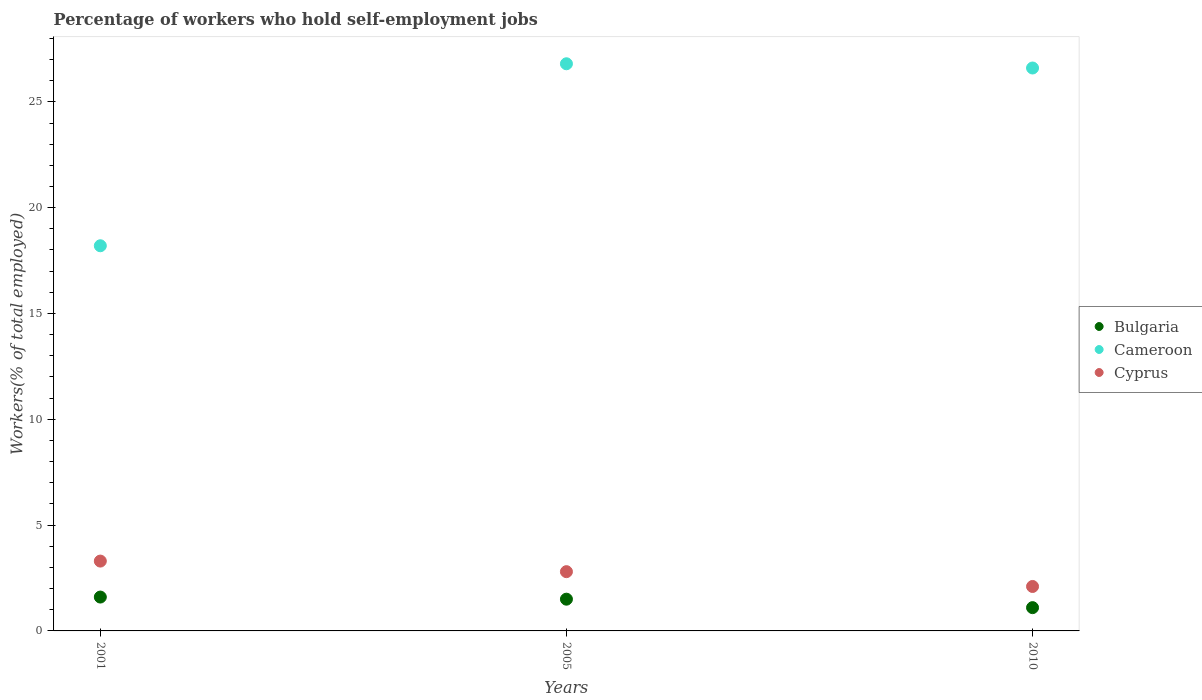How many different coloured dotlines are there?
Make the answer very short. 3. What is the percentage of self-employed workers in Cyprus in 2001?
Provide a succinct answer. 3.3. Across all years, what is the maximum percentage of self-employed workers in Cyprus?
Make the answer very short. 3.3. Across all years, what is the minimum percentage of self-employed workers in Bulgaria?
Your answer should be very brief. 1.1. In which year was the percentage of self-employed workers in Bulgaria maximum?
Offer a very short reply. 2001. What is the total percentage of self-employed workers in Bulgaria in the graph?
Your response must be concise. 4.2. What is the difference between the percentage of self-employed workers in Cameroon in 2005 and that in 2010?
Offer a very short reply. 0.2. What is the difference between the percentage of self-employed workers in Cameroon in 2005 and the percentage of self-employed workers in Bulgaria in 2010?
Make the answer very short. 25.7. What is the average percentage of self-employed workers in Cyprus per year?
Keep it short and to the point. 2.73. In the year 2010, what is the difference between the percentage of self-employed workers in Cameroon and percentage of self-employed workers in Bulgaria?
Ensure brevity in your answer.  25.5. In how many years, is the percentage of self-employed workers in Bulgaria greater than 6 %?
Offer a very short reply. 0. What is the ratio of the percentage of self-employed workers in Cameroon in 2001 to that in 2005?
Your answer should be compact. 0.68. Is the difference between the percentage of self-employed workers in Cameroon in 2001 and 2010 greater than the difference between the percentage of self-employed workers in Bulgaria in 2001 and 2010?
Offer a terse response. No. What is the difference between the highest and the lowest percentage of self-employed workers in Cameroon?
Ensure brevity in your answer.  8.6. Is the sum of the percentage of self-employed workers in Bulgaria in 2001 and 2005 greater than the maximum percentage of self-employed workers in Cameroon across all years?
Offer a terse response. No. Is it the case that in every year, the sum of the percentage of self-employed workers in Cameroon and percentage of self-employed workers in Bulgaria  is greater than the percentage of self-employed workers in Cyprus?
Make the answer very short. Yes. Does the percentage of self-employed workers in Bulgaria monotonically increase over the years?
Offer a very short reply. No. Is the percentage of self-employed workers in Cameroon strictly less than the percentage of self-employed workers in Bulgaria over the years?
Offer a very short reply. No. How many dotlines are there?
Ensure brevity in your answer.  3. How many years are there in the graph?
Your answer should be very brief. 3. What is the difference between two consecutive major ticks on the Y-axis?
Give a very brief answer. 5. Does the graph contain any zero values?
Offer a very short reply. No. Does the graph contain grids?
Offer a terse response. No. Where does the legend appear in the graph?
Your answer should be very brief. Center right. How many legend labels are there?
Give a very brief answer. 3. What is the title of the graph?
Ensure brevity in your answer.  Percentage of workers who hold self-employment jobs. Does "Virgin Islands" appear as one of the legend labels in the graph?
Ensure brevity in your answer.  No. What is the label or title of the X-axis?
Provide a succinct answer. Years. What is the label or title of the Y-axis?
Offer a terse response. Workers(% of total employed). What is the Workers(% of total employed) in Bulgaria in 2001?
Provide a succinct answer. 1.6. What is the Workers(% of total employed) of Cameroon in 2001?
Offer a terse response. 18.2. What is the Workers(% of total employed) in Cyprus in 2001?
Your answer should be very brief. 3.3. What is the Workers(% of total employed) of Cameroon in 2005?
Provide a short and direct response. 26.8. What is the Workers(% of total employed) of Cyprus in 2005?
Provide a succinct answer. 2.8. What is the Workers(% of total employed) of Bulgaria in 2010?
Offer a very short reply. 1.1. What is the Workers(% of total employed) of Cameroon in 2010?
Keep it short and to the point. 26.6. What is the Workers(% of total employed) of Cyprus in 2010?
Ensure brevity in your answer.  2.1. Across all years, what is the maximum Workers(% of total employed) of Bulgaria?
Ensure brevity in your answer.  1.6. Across all years, what is the maximum Workers(% of total employed) in Cameroon?
Your response must be concise. 26.8. Across all years, what is the maximum Workers(% of total employed) of Cyprus?
Provide a short and direct response. 3.3. Across all years, what is the minimum Workers(% of total employed) of Bulgaria?
Provide a succinct answer. 1.1. Across all years, what is the minimum Workers(% of total employed) in Cameroon?
Keep it short and to the point. 18.2. Across all years, what is the minimum Workers(% of total employed) of Cyprus?
Ensure brevity in your answer.  2.1. What is the total Workers(% of total employed) of Cameroon in the graph?
Make the answer very short. 71.6. What is the difference between the Workers(% of total employed) of Bulgaria in 2001 and that in 2005?
Your answer should be compact. 0.1. What is the difference between the Workers(% of total employed) of Bulgaria in 2001 and that in 2010?
Provide a short and direct response. 0.5. What is the difference between the Workers(% of total employed) of Cameroon in 2001 and that in 2010?
Give a very brief answer. -8.4. What is the difference between the Workers(% of total employed) of Bulgaria in 2005 and that in 2010?
Keep it short and to the point. 0.4. What is the difference between the Workers(% of total employed) in Cameroon in 2005 and that in 2010?
Ensure brevity in your answer.  0.2. What is the difference between the Workers(% of total employed) in Bulgaria in 2001 and the Workers(% of total employed) in Cameroon in 2005?
Your answer should be very brief. -25.2. What is the difference between the Workers(% of total employed) in Cameroon in 2001 and the Workers(% of total employed) in Cyprus in 2005?
Offer a terse response. 15.4. What is the difference between the Workers(% of total employed) in Cameroon in 2001 and the Workers(% of total employed) in Cyprus in 2010?
Offer a terse response. 16.1. What is the difference between the Workers(% of total employed) of Bulgaria in 2005 and the Workers(% of total employed) of Cameroon in 2010?
Offer a terse response. -25.1. What is the difference between the Workers(% of total employed) in Bulgaria in 2005 and the Workers(% of total employed) in Cyprus in 2010?
Offer a terse response. -0.6. What is the difference between the Workers(% of total employed) in Cameroon in 2005 and the Workers(% of total employed) in Cyprus in 2010?
Your answer should be compact. 24.7. What is the average Workers(% of total employed) in Cameroon per year?
Provide a succinct answer. 23.87. What is the average Workers(% of total employed) in Cyprus per year?
Provide a short and direct response. 2.73. In the year 2001, what is the difference between the Workers(% of total employed) in Bulgaria and Workers(% of total employed) in Cameroon?
Give a very brief answer. -16.6. In the year 2001, what is the difference between the Workers(% of total employed) in Bulgaria and Workers(% of total employed) in Cyprus?
Your response must be concise. -1.7. In the year 2001, what is the difference between the Workers(% of total employed) in Cameroon and Workers(% of total employed) in Cyprus?
Offer a very short reply. 14.9. In the year 2005, what is the difference between the Workers(% of total employed) in Bulgaria and Workers(% of total employed) in Cameroon?
Provide a succinct answer. -25.3. In the year 2010, what is the difference between the Workers(% of total employed) in Bulgaria and Workers(% of total employed) in Cameroon?
Keep it short and to the point. -25.5. In the year 2010, what is the difference between the Workers(% of total employed) in Bulgaria and Workers(% of total employed) in Cyprus?
Give a very brief answer. -1. In the year 2010, what is the difference between the Workers(% of total employed) of Cameroon and Workers(% of total employed) of Cyprus?
Your answer should be very brief. 24.5. What is the ratio of the Workers(% of total employed) in Bulgaria in 2001 to that in 2005?
Make the answer very short. 1.07. What is the ratio of the Workers(% of total employed) of Cameroon in 2001 to that in 2005?
Your answer should be compact. 0.68. What is the ratio of the Workers(% of total employed) in Cyprus in 2001 to that in 2005?
Provide a succinct answer. 1.18. What is the ratio of the Workers(% of total employed) in Bulgaria in 2001 to that in 2010?
Ensure brevity in your answer.  1.45. What is the ratio of the Workers(% of total employed) in Cameroon in 2001 to that in 2010?
Provide a short and direct response. 0.68. What is the ratio of the Workers(% of total employed) of Cyprus in 2001 to that in 2010?
Provide a short and direct response. 1.57. What is the ratio of the Workers(% of total employed) in Bulgaria in 2005 to that in 2010?
Offer a terse response. 1.36. What is the ratio of the Workers(% of total employed) of Cameroon in 2005 to that in 2010?
Your answer should be very brief. 1.01. What is the difference between the highest and the second highest Workers(% of total employed) in Cyprus?
Your answer should be very brief. 0.5. What is the difference between the highest and the lowest Workers(% of total employed) in Bulgaria?
Ensure brevity in your answer.  0.5. What is the difference between the highest and the lowest Workers(% of total employed) of Cyprus?
Your answer should be very brief. 1.2. 